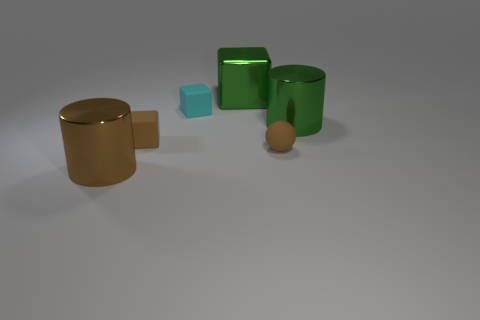Subtract all small cubes. How many cubes are left? 1 Add 1 large green blocks. How many objects exist? 7 Subtract all green cylinders. How many cylinders are left? 1 Subtract all cylinders. How many objects are left? 4 Subtract all yellow spheres. Subtract all brown cubes. How many spheres are left? 1 Subtract all red spheres. How many brown cylinders are left? 1 Subtract all small brown metallic balls. Subtract all tiny brown objects. How many objects are left? 4 Add 1 small brown spheres. How many small brown spheres are left? 2 Add 1 small red metal spheres. How many small red metal spheres exist? 1 Subtract 1 brown blocks. How many objects are left? 5 